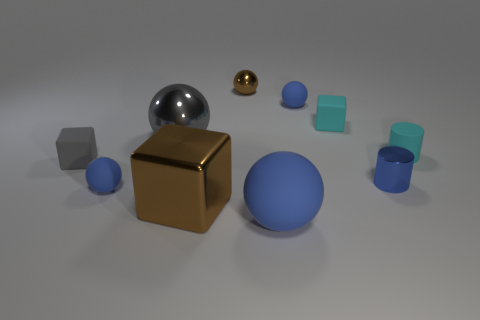Subtract all large gray metallic spheres. How many spheres are left? 4 Subtract all yellow blocks. How many blue spheres are left? 3 Subtract all blue cylinders. How many cylinders are left? 1 Subtract 1 balls. How many balls are left? 4 Subtract all tiny purple metallic spheres. Subtract all tiny gray cubes. How many objects are left? 9 Add 5 tiny blue metal cylinders. How many tiny blue metal cylinders are left? 6 Add 2 brown rubber spheres. How many brown rubber spheres exist? 2 Subtract 0 red cylinders. How many objects are left? 10 Subtract all cylinders. How many objects are left? 8 Subtract all blue blocks. Subtract all cyan spheres. How many blocks are left? 3 